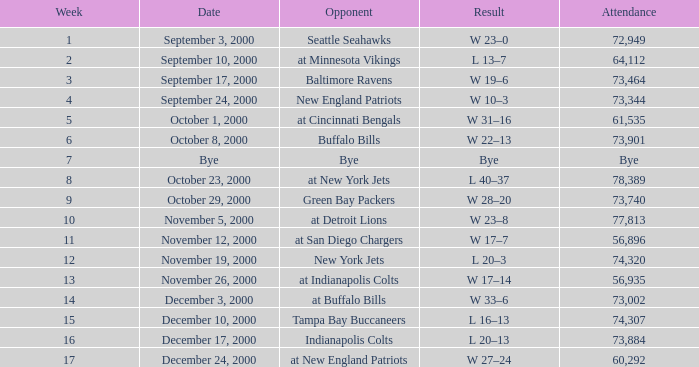What is the outcome of the match against the indianapolis colts? L 20–13. 